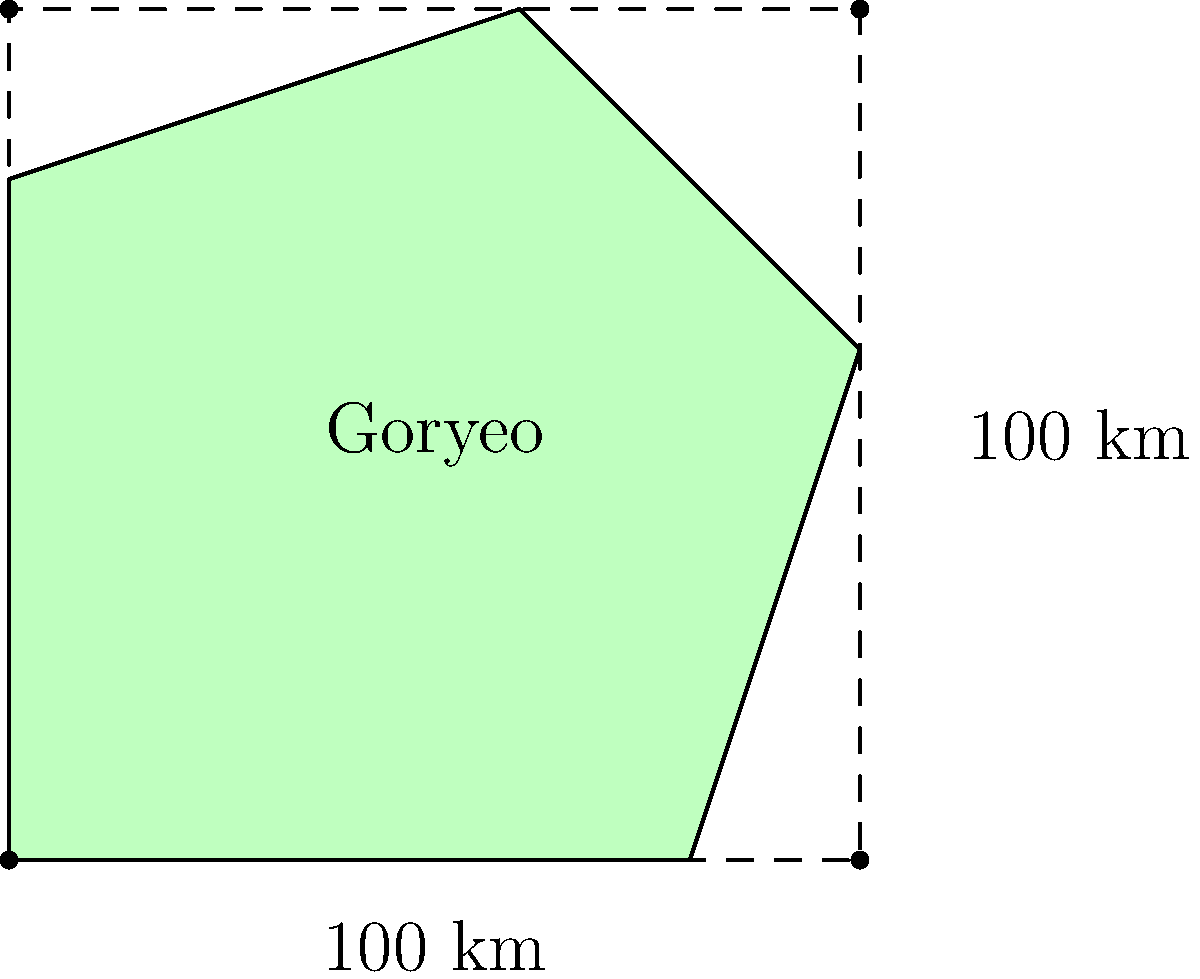As a historian specializing in the Goryeo Dynasty, you've come across a simplified map representation of the Goryeo Kingdom's territory. The map is enclosed within a 100 km x 100 km square for scale. If you were to estimate the land area of the Goryeo Kingdom using basic geometric shapes, what would be your best approximation in square kilometers? (Round your answer to the nearest thousand sq km) To estimate the land area of the Goryeo Kingdom using the given map, we can follow these steps:

1. Observe that the shape of Goryeo Kingdom can be approximated by a pentagon.

2. We can divide this pentagon into simpler shapes: a rectangle and a triangle.

3. Let's estimate the dimensions:
   - The base of the shape is about 80 km
   - The height at the tallest point is about 100 km
   - The width at the top is about 60 km

4. Calculate the area of the rectangle:
   $$A_{rectangle} = 80 \text{ km} \times 80 \text{ km} = 6,400 \text{ sq km}$$

5. Calculate the area of the triangle:
   Base of triangle ≈ 60 km
   Height of triangle ≈ 20 km
   $$A_{triangle} = \frac{1}{2} \times 60 \text{ km} \times 20 \text{ km} = 600 \text{ sq km}$$

6. Sum up the areas:
   $$A_{total} = A_{rectangle} + A_{triangle} = 6,400 + 600 = 7,000 \text{ sq km}$$

7. Round to the nearest thousand:
   7,000 sq km

This method provides a rough estimate based on simplifying the complex shape into basic geometric forms. As a historian, you would understand that this is a approximation and actual borders would have been more complex.
Answer: 7,000 sq km 